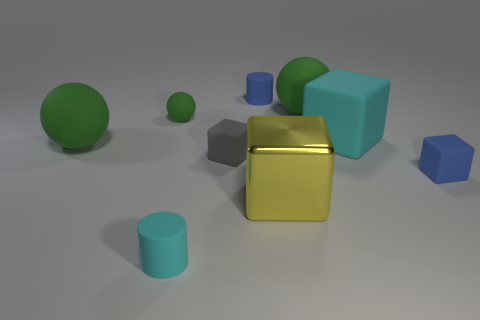Is there anything else that has the same material as the large yellow thing?
Keep it short and to the point. No. What color is the thing that is both to the right of the gray object and in front of the blue matte block?
Provide a succinct answer. Yellow. Is the big yellow object made of the same material as the blue object that is behind the tiny gray block?
Offer a terse response. No. Is the number of big yellow blocks behind the gray thing less than the number of small blue spheres?
Offer a very short reply. No. What number of other objects are the same shape as the yellow shiny thing?
Offer a terse response. 3. Is there any other thing that has the same color as the tiny rubber ball?
Your answer should be compact. Yes. There is a tiny rubber sphere; is its color the same as the large object on the left side of the tiny cyan matte cylinder?
Offer a terse response. Yes. What number of other objects are there of the same size as the gray rubber block?
Keep it short and to the point. 4. What number of cylinders are either green rubber objects or blue matte things?
Provide a short and direct response. 1. Do the small blue matte object that is behind the tiny green ball and the small cyan object have the same shape?
Give a very brief answer. Yes. 